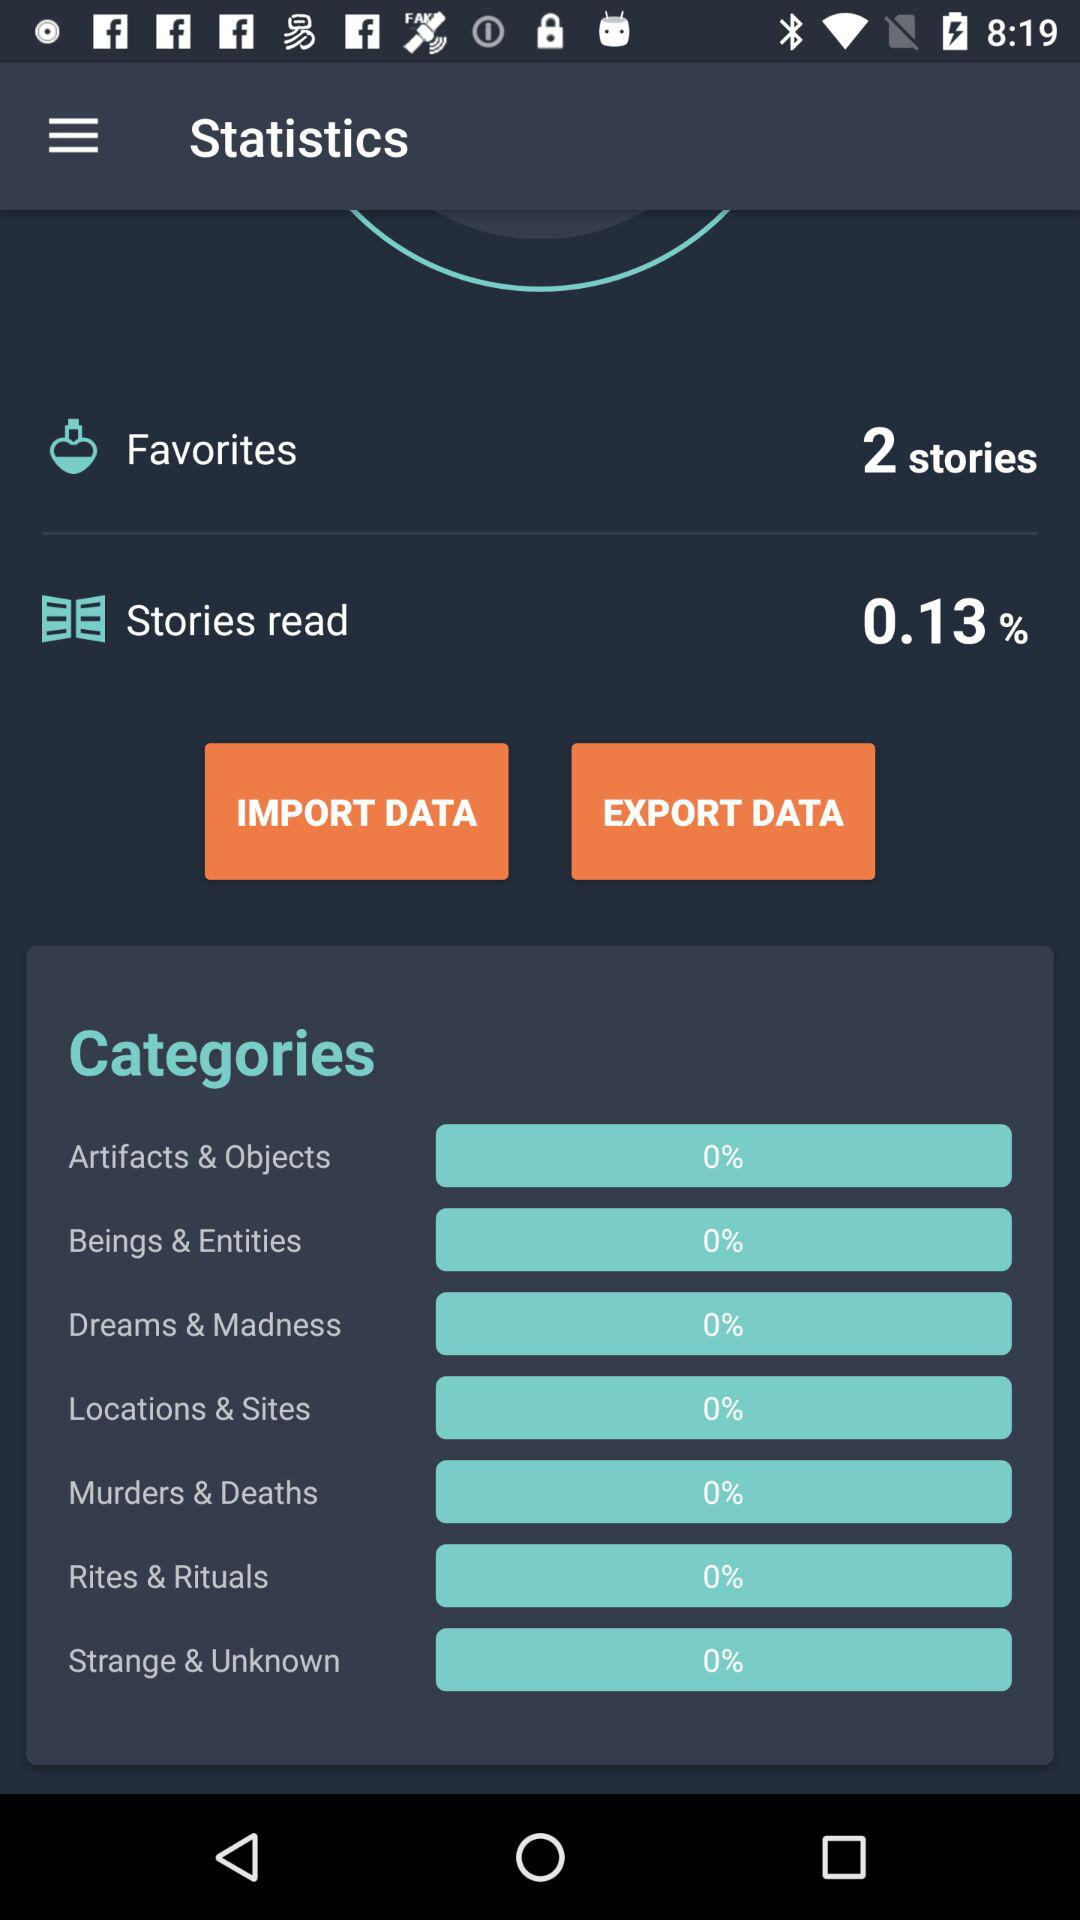What is the percentage of stories read? The percentage of stories read is 0.13. 